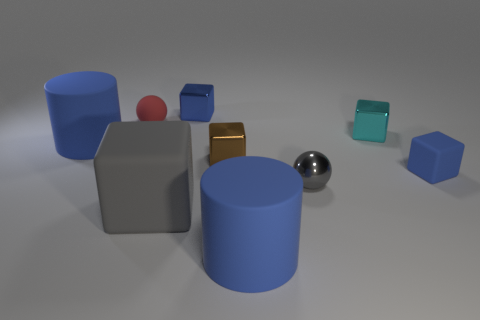Subtract all cyan metallic cubes. How many cubes are left? 4 Subtract all brown cubes. How many cubes are left? 4 Subtract all yellow cylinders. How many blue blocks are left? 2 Subtract 3 blocks. How many blocks are left? 2 Subtract all blocks. How many objects are left? 4 Subtract all yellow balls. Subtract all purple cylinders. How many balls are left? 2 Subtract all small blue cubes. Subtract all small cyan metal blocks. How many objects are left? 6 Add 3 large blue rubber cylinders. How many large blue rubber cylinders are left? 5 Add 6 small blue objects. How many small blue objects exist? 8 Subtract 2 blue cubes. How many objects are left? 7 